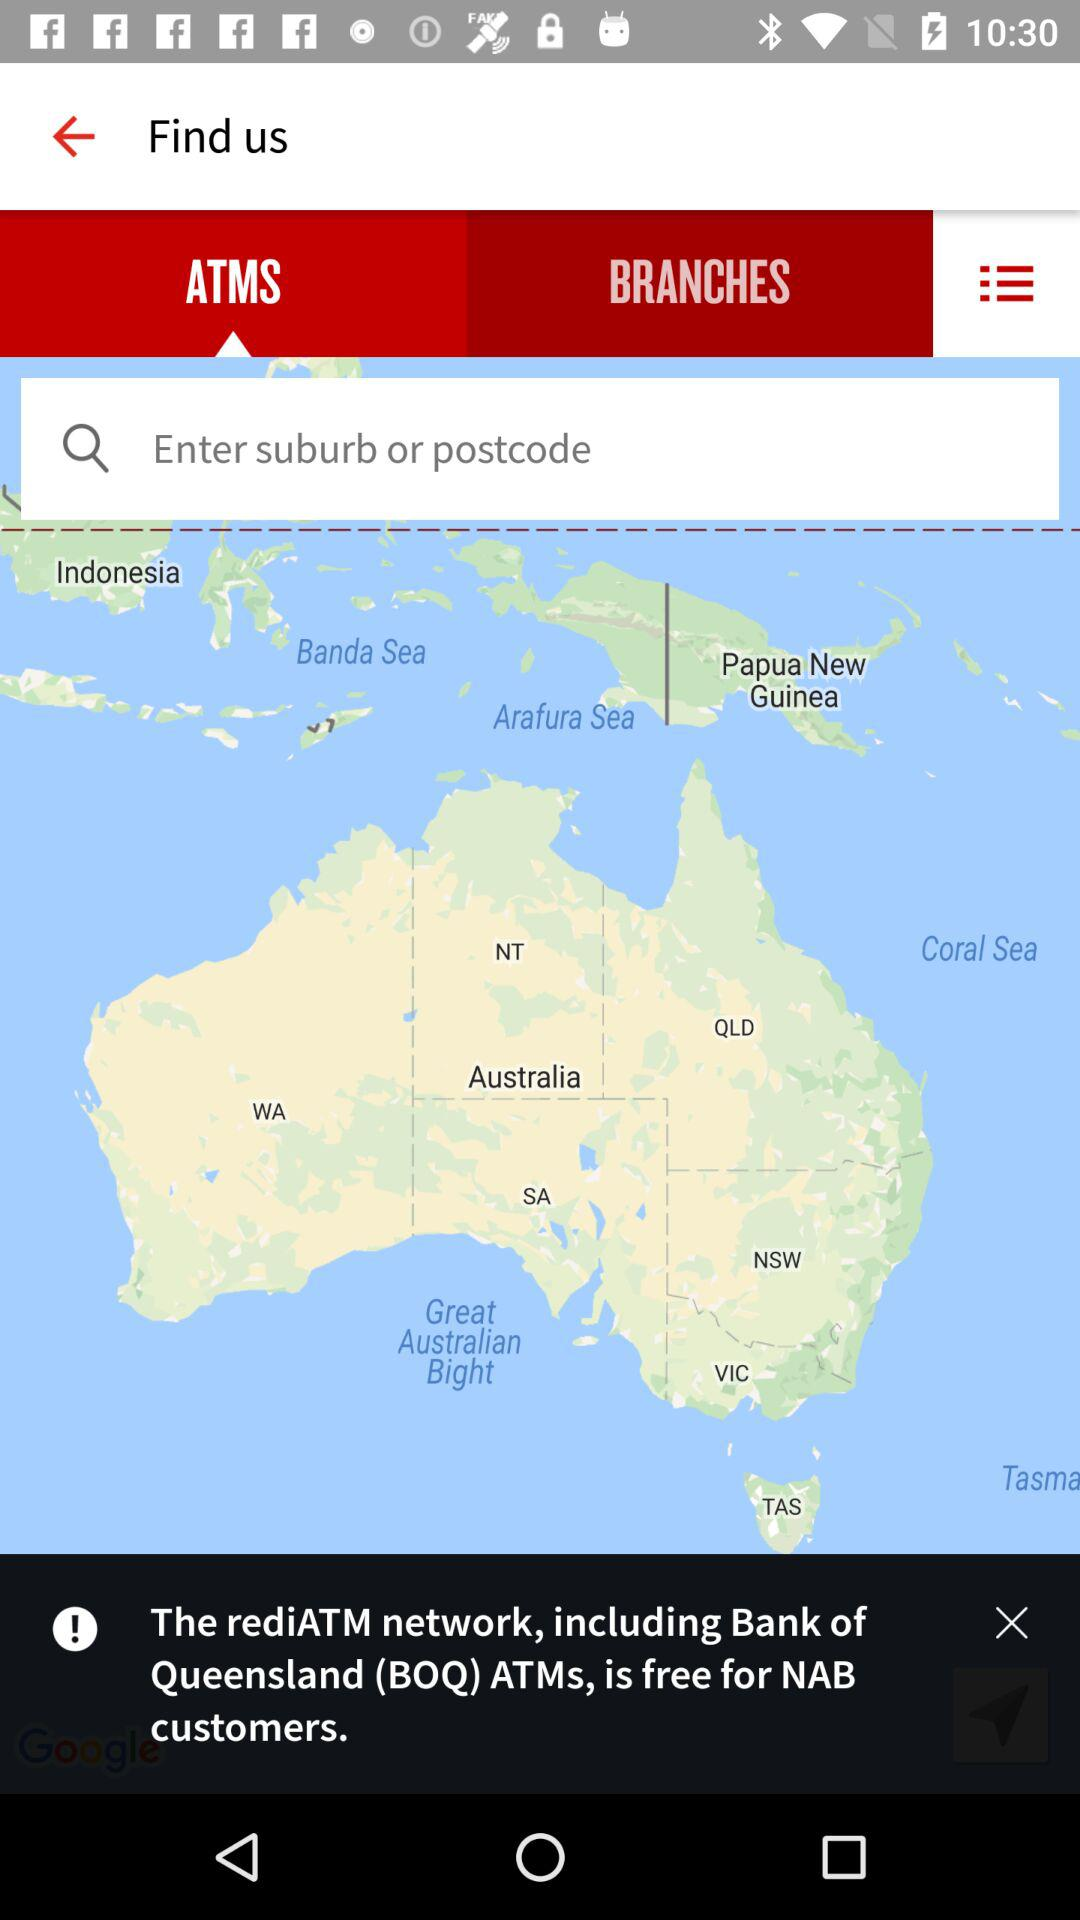What is the entered postcode?
When the provided information is insufficient, respond with <no answer>. <no answer> 